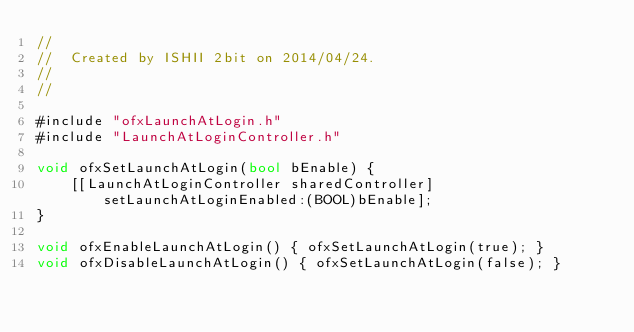Convert code to text. <code><loc_0><loc_0><loc_500><loc_500><_ObjectiveC_>//
//  Created by ISHII 2bit on 2014/04/24.
//
//

#include "ofxLaunchAtLogin.h"
#include "LaunchAtLoginController.h"

void ofxSetLaunchAtLogin(bool bEnable) {
    [[LaunchAtLoginController sharedController] setLaunchAtLoginEnabled:(BOOL)bEnable];
}

void ofxEnableLaunchAtLogin() { ofxSetLaunchAtLogin(true); }
void ofxDisableLaunchAtLogin() { ofxSetLaunchAtLogin(false); }
</code> 